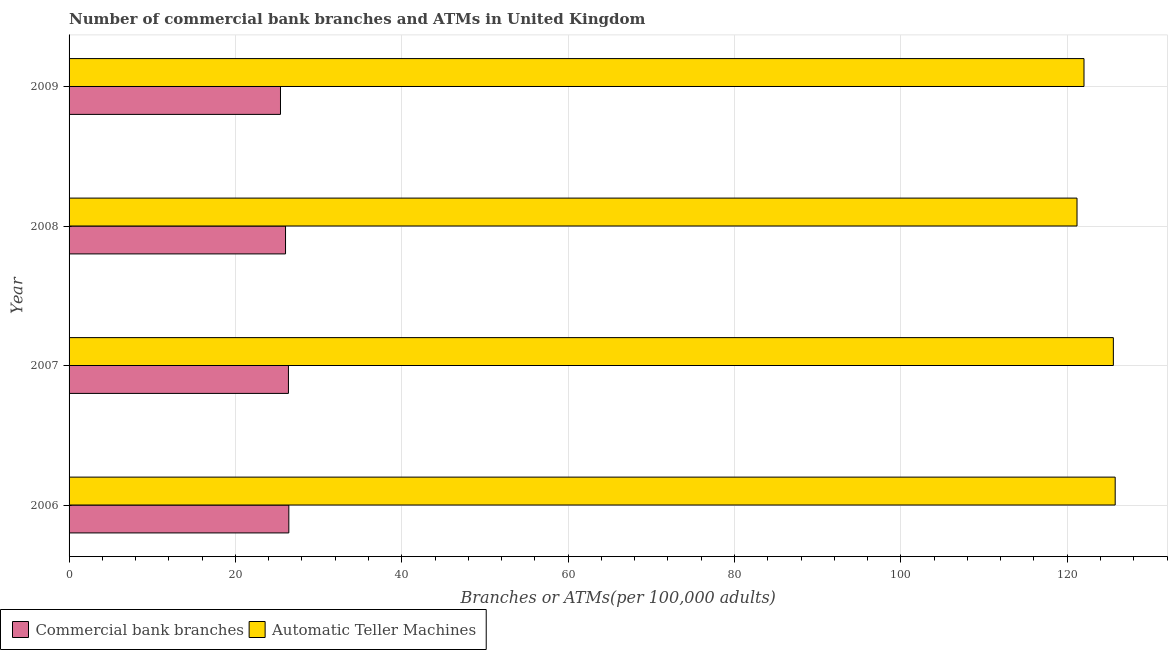How many different coloured bars are there?
Your answer should be compact. 2. Are the number of bars per tick equal to the number of legend labels?
Offer a terse response. Yes. Are the number of bars on each tick of the Y-axis equal?
Your answer should be compact. Yes. What is the number of commercal bank branches in 2006?
Make the answer very short. 26.42. Across all years, what is the maximum number of atms?
Offer a very short reply. 125.77. Across all years, what is the minimum number of commercal bank branches?
Your answer should be very brief. 25.42. What is the total number of commercal bank branches in the graph?
Make the answer very short. 104.23. What is the difference between the number of commercal bank branches in 2006 and that in 2008?
Your answer should be very brief. 0.4. What is the difference between the number of commercal bank branches in 2008 and the number of atms in 2007?
Your answer should be very brief. -99.52. What is the average number of commercal bank branches per year?
Make the answer very short. 26.06. In the year 2006, what is the difference between the number of commercal bank branches and number of atms?
Ensure brevity in your answer.  -99.35. What is the ratio of the number of atms in 2006 to that in 2007?
Provide a succinct answer. 1. Is the number of commercal bank branches in 2008 less than that in 2009?
Provide a short and direct response. No. Is the difference between the number of atms in 2008 and 2009 greater than the difference between the number of commercal bank branches in 2008 and 2009?
Your answer should be compact. No. What is the difference between the highest and the second highest number of atms?
Keep it short and to the point. 0.22. What is the difference between the highest and the lowest number of atms?
Offer a very short reply. 4.59. Is the sum of the number of atms in 2008 and 2009 greater than the maximum number of commercal bank branches across all years?
Provide a succinct answer. Yes. What does the 1st bar from the top in 2006 represents?
Offer a very short reply. Automatic Teller Machines. What does the 1st bar from the bottom in 2006 represents?
Give a very brief answer. Commercial bank branches. Are all the bars in the graph horizontal?
Keep it short and to the point. Yes. How many years are there in the graph?
Your answer should be compact. 4. What is the difference between two consecutive major ticks on the X-axis?
Your answer should be very brief. 20. Where does the legend appear in the graph?
Keep it short and to the point. Bottom left. How many legend labels are there?
Your answer should be compact. 2. How are the legend labels stacked?
Your answer should be compact. Horizontal. What is the title of the graph?
Your response must be concise. Number of commercial bank branches and ATMs in United Kingdom. Does "GDP" appear as one of the legend labels in the graph?
Give a very brief answer. No. What is the label or title of the X-axis?
Make the answer very short. Branches or ATMs(per 100,0 adults). What is the label or title of the Y-axis?
Your answer should be very brief. Year. What is the Branches or ATMs(per 100,000 adults) in Commercial bank branches in 2006?
Make the answer very short. 26.42. What is the Branches or ATMs(per 100,000 adults) of Automatic Teller Machines in 2006?
Your response must be concise. 125.77. What is the Branches or ATMs(per 100,000 adults) of Commercial bank branches in 2007?
Your answer should be compact. 26.37. What is the Branches or ATMs(per 100,000 adults) in Automatic Teller Machines in 2007?
Your answer should be very brief. 125.55. What is the Branches or ATMs(per 100,000 adults) of Commercial bank branches in 2008?
Provide a short and direct response. 26.02. What is the Branches or ATMs(per 100,000 adults) in Automatic Teller Machines in 2008?
Make the answer very short. 121.18. What is the Branches or ATMs(per 100,000 adults) in Commercial bank branches in 2009?
Give a very brief answer. 25.42. What is the Branches or ATMs(per 100,000 adults) in Automatic Teller Machines in 2009?
Offer a terse response. 122.02. Across all years, what is the maximum Branches or ATMs(per 100,000 adults) in Commercial bank branches?
Provide a succinct answer. 26.42. Across all years, what is the maximum Branches or ATMs(per 100,000 adults) of Automatic Teller Machines?
Provide a short and direct response. 125.77. Across all years, what is the minimum Branches or ATMs(per 100,000 adults) of Commercial bank branches?
Your answer should be very brief. 25.42. Across all years, what is the minimum Branches or ATMs(per 100,000 adults) of Automatic Teller Machines?
Your answer should be very brief. 121.18. What is the total Branches or ATMs(per 100,000 adults) of Commercial bank branches in the graph?
Make the answer very short. 104.23. What is the total Branches or ATMs(per 100,000 adults) in Automatic Teller Machines in the graph?
Offer a terse response. 494.51. What is the difference between the Branches or ATMs(per 100,000 adults) of Commercial bank branches in 2006 and that in 2007?
Your response must be concise. 0.05. What is the difference between the Branches or ATMs(per 100,000 adults) of Automatic Teller Machines in 2006 and that in 2007?
Offer a very short reply. 0.22. What is the difference between the Branches or ATMs(per 100,000 adults) of Commercial bank branches in 2006 and that in 2008?
Give a very brief answer. 0.4. What is the difference between the Branches or ATMs(per 100,000 adults) of Automatic Teller Machines in 2006 and that in 2008?
Your answer should be compact. 4.59. What is the difference between the Branches or ATMs(per 100,000 adults) in Commercial bank branches in 2006 and that in 2009?
Offer a terse response. 1. What is the difference between the Branches or ATMs(per 100,000 adults) of Automatic Teller Machines in 2006 and that in 2009?
Make the answer very short. 3.75. What is the difference between the Branches or ATMs(per 100,000 adults) in Commercial bank branches in 2007 and that in 2008?
Provide a short and direct response. 0.35. What is the difference between the Branches or ATMs(per 100,000 adults) in Automatic Teller Machines in 2007 and that in 2008?
Offer a terse response. 4.37. What is the difference between the Branches or ATMs(per 100,000 adults) of Commercial bank branches in 2007 and that in 2009?
Your answer should be compact. 0.96. What is the difference between the Branches or ATMs(per 100,000 adults) in Automatic Teller Machines in 2007 and that in 2009?
Your response must be concise. 3.53. What is the difference between the Branches or ATMs(per 100,000 adults) in Commercial bank branches in 2008 and that in 2009?
Keep it short and to the point. 0.61. What is the difference between the Branches or ATMs(per 100,000 adults) in Automatic Teller Machines in 2008 and that in 2009?
Offer a very short reply. -0.84. What is the difference between the Branches or ATMs(per 100,000 adults) of Commercial bank branches in 2006 and the Branches or ATMs(per 100,000 adults) of Automatic Teller Machines in 2007?
Provide a short and direct response. -99.13. What is the difference between the Branches or ATMs(per 100,000 adults) in Commercial bank branches in 2006 and the Branches or ATMs(per 100,000 adults) in Automatic Teller Machines in 2008?
Offer a terse response. -94.76. What is the difference between the Branches or ATMs(per 100,000 adults) in Commercial bank branches in 2006 and the Branches or ATMs(per 100,000 adults) in Automatic Teller Machines in 2009?
Offer a terse response. -95.6. What is the difference between the Branches or ATMs(per 100,000 adults) in Commercial bank branches in 2007 and the Branches or ATMs(per 100,000 adults) in Automatic Teller Machines in 2008?
Give a very brief answer. -94.8. What is the difference between the Branches or ATMs(per 100,000 adults) of Commercial bank branches in 2007 and the Branches or ATMs(per 100,000 adults) of Automatic Teller Machines in 2009?
Your response must be concise. -95.64. What is the difference between the Branches or ATMs(per 100,000 adults) in Commercial bank branches in 2008 and the Branches or ATMs(per 100,000 adults) in Automatic Teller Machines in 2009?
Your response must be concise. -95.99. What is the average Branches or ATMs(per 100,000 adults) in Commercial bank branches per year?
Your answer should be compact. 26.06. What is the average Branches or ATMs(per 100,000 adults) of Automatic Teller Machines per year?
Your response must be concise. 123.63. In the year 2006, what is the difference between the Branches or ATMs(per 100,000 adults) in Commercial bank branches and Branches or ATMs(per 100,000 adults) in Automatic Teller Machines?
Make the answer very short. -99.35. In the year 2007, what is the difference between the Branches or ATMs(per 100,000 adults) in Commercial bank branches and Branches or ATMs(per 100,000 adults) in Automatic Teller Machines?
Offer a very short reply. -99.17. In the year 2008, what is the difference between the Branches or ATMs(per 100,000 adults) in Commercial bank branches and Branches or ATMs(per 100,000 adults) in Automatic Teller Machines?
Ensure brevity in your answer.  -95.15. In the year 2009, what is the difference between the Branches or ATMs(per 100,000 adults) in Commercial bank branches and Branches or ATMs(per 100,000 adults) in Automatic Teller Machines?
Your answer should be very brief. -96.6. What is the ratio of the Branches or ATMs(per 100,000 adults) in Automatic Teller Machines in 2006 to that in 2007?
Your response must be concise. 1. What is the ratio of the Branches or ATMs(per 100,000 adults) of Commercial bank branches in 2006 to that in 2008?
Your answer should be compact. 1.02. What is the ratio of the Branches or ATMs(per 100,000 adults) of Automatic Teller Machines in 2006 to that in 2008?
Offer a very short reply. 1.04. What is the ratio of the Branches or ATMs(per 100,000 adults) in Commercial bank branches in 2006 to that in 2009?
Provide a succinct answer. 1.04. What is the ratio of the Branches or ATMs(per 100,000 adults) in Automatic Teller Machines in 2006 to that in 2009?
Offer a very short reply. 1.03. What is the ratio of the Branches or ATMs(per 100,000 adults) of Commercial bank branches in 2007 to that in 2008?
Ensure brevity in your answer.  1.01. What is the ratio of the Branches or ATMs(per 100,000 adults) in Automatic Teller Machines in 2007 to that in 2008?
Offer a very short reply. 1.04. What is the ratio of the Branches or ATMs(per 100,000 adults) in Commercial bank branches in 2007 to that in 2009?
Give a very brief answer. 1.04. What is the ratio of the Branches or ATMs(per 100,000 adults) of Automatic Teller Machines in 2007 to that in 2009?
Your answer should be compact. 1.03. What is the ratio of the Branches or ATMs(per 100,000 adults) in Commercial bank branches in 2008 to that in 2009?
Offer a very short reply. 1.02. What is the difference between the highest and the second highest Branches or ATMs(per 100,000 adults) of Commercial bank branches?
Make the answer very short. 0.05. What is the difference between the highest and the second highest Branches or ATMs(per 100,000 adults) in Automatic Teller Machines?
Offer a terse response. 0.22. What is the difference between the highest and the lowest Branches or ATMs(per 100,000 adults) in Commercial bank branches?
Offer a terse response. 1. What is the difference between the highest and the lowest Branches or ATMs(per 100,000 adults) in Automatic Teller Machines?
Give a very brief answer. 4.59. 